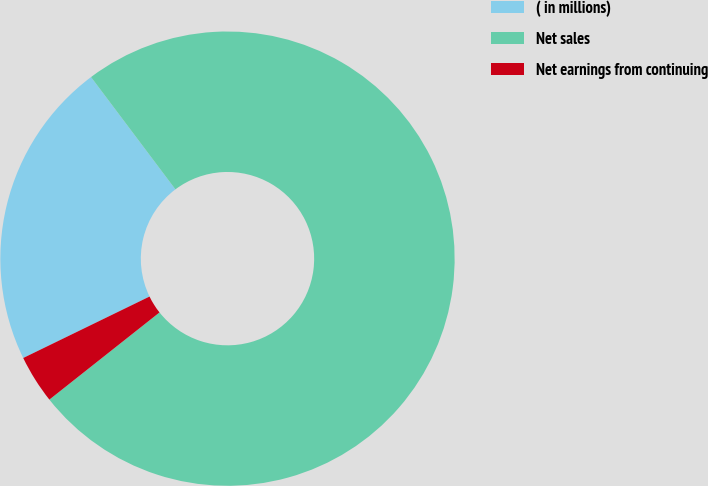Convert chart to OTSL. <chart><loc_0><loc_0><loc_500><loc_500><pie_chart><fcel>( in millions)<fcel>Net sales<fcel>Net earnings from continuing<nl><fcel>21.95%<fcel>74.61%<fcel>3.45%<nl></chart> 